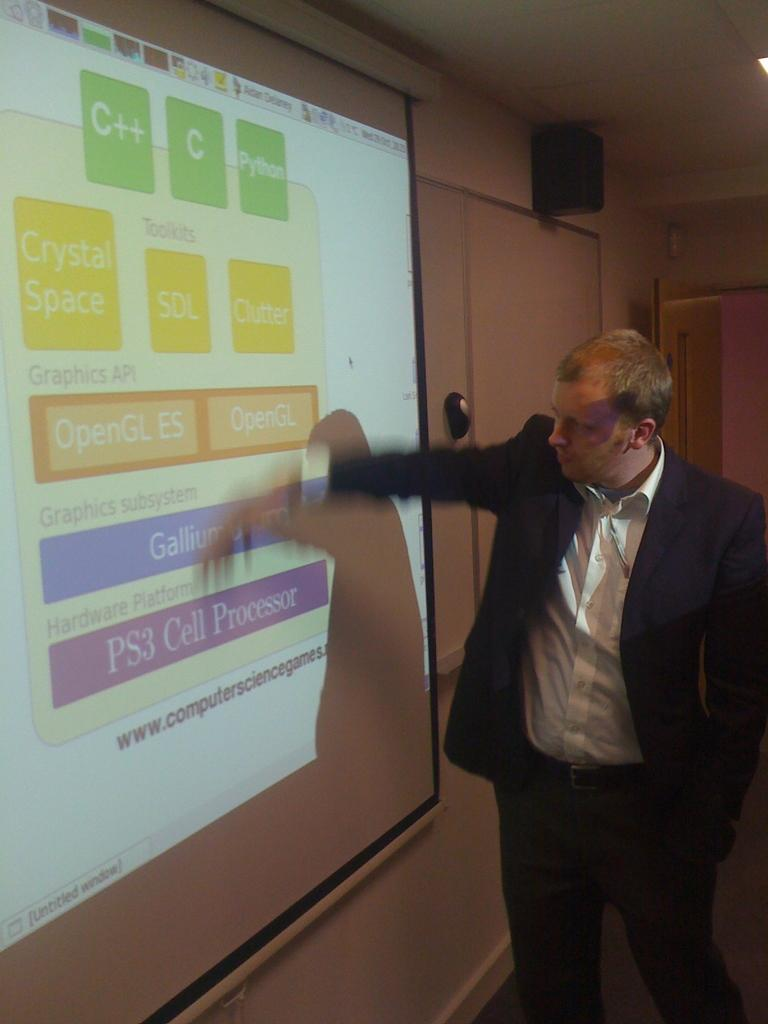<image>
Render a clear and concise summary of the photo. A man gestures at a projection of an image from the compter science games website. 